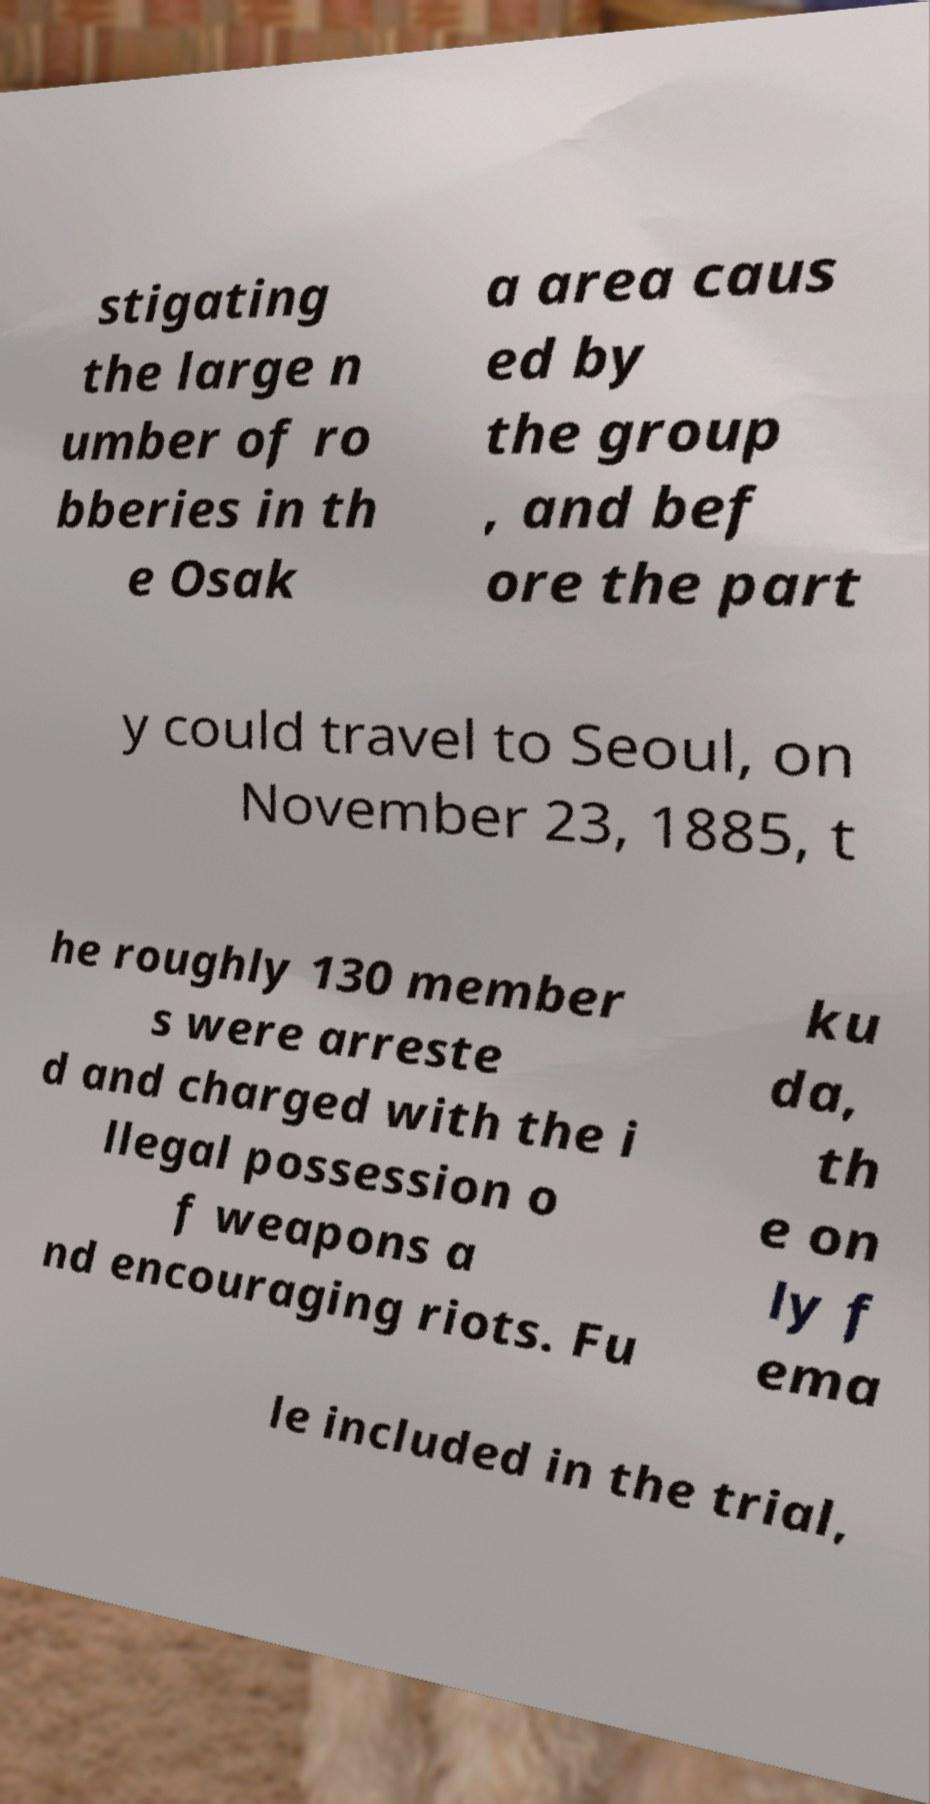Could you assist in decoding the text presented in this image and type it out clearly? stigating the large n umber of ro bberies in th e Osak a area caus ed by the group , and bef ore the part y could travel to Seoul, on November 23, 1885, t he roughly 130 member s were arreste d and charged with the i llegal possession o f weapons a nd encouraging riots. Fu ku da, th e on ly f ema le included in the trial, 